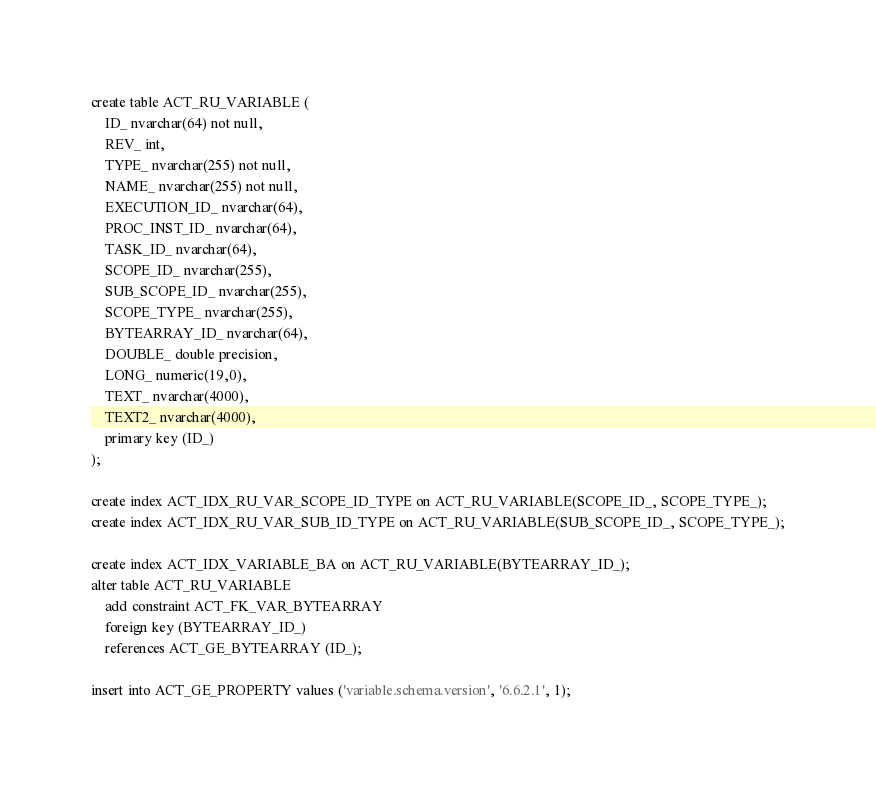Convert code to text. <code><loc_0><loc_0><loc_500><loc_500><_SQL_>create table ACT_RU_VARIABLE (
    ID_ nvarchar(64) not null,
    REV_ int,
    TYPE_ nvarchar(255) not null,
    NAME_ nvarchar(255) not null,
    EXECUTION_ID_ nvarchar(64),
    PROC_INST_ID_ nvarchar(64),
    TASK_ID_ nvarchar(64),
    SCOPE_ID_ nvarchar(255),
    SUB_SCOPE_ID_ nvarchar(255),
    SCOPE_TYPE_ nvarchar(255),
    BYTEARRAY_ID_ nvarchar(64),
    DOUBLE_ double precision,
    LONG_ numeric(19,0),
    TEXT_ nvarchar(4000),
    TEXT2_ nvarchar(4000),
    primary key (ID_)
);

create index ACT_IDX_RU_VAR_SCOPE_ID_TYPE on ACT_RU_VARIABLE(SCOPE_ID_, SCOPE_TYPE_);
create index ACT_IDX_RU_VAR_SUB_ID_TYPE on ACT_RU_VARIABLE(SUB_SCOPE_ID_, SCOPE_TYPE_);

create index ACT_IDX_VARIABLE_BA on ACT_RU_VARIABLE(BYTEARRAY_ID_);
alter table ACT_RU_VARIABLE 
    add constraint ACT_FK_VAR_BYTEARRAY 
    foreign key (BYTEARRAY_ID_) 
    references ACT_GE_BYTEARRAY (ID_);

insert into ACT_GE_PROPERTY values ('variable.schema.version', '6.6.2.1', 1);
</code> 